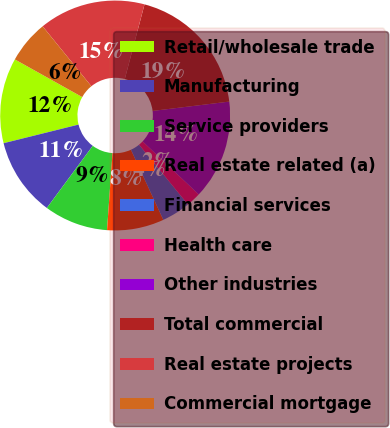<chart> <loc_0><loc_0><loc_500><loc_500><pie_chart><fcel>Retail/wholesale trade<fcel>Manufacturing<fcel>Service providers<fcel>Real estate related (a)<fcel>Financial services<fcel>Health care<fcel>Other industries<fcel>Total commercial<fcel>Real estate projects<fcel>Commercial mortgage<nl><fcel>11.99%<fcel>11.0%<fcel>9.0%<fcel>8.01%<fcel>4.03%<fcel>2.04%<fcel>13.98%<fcel>18.96%<fcel>14.98%<fcel>6.02%<nl></chart> 